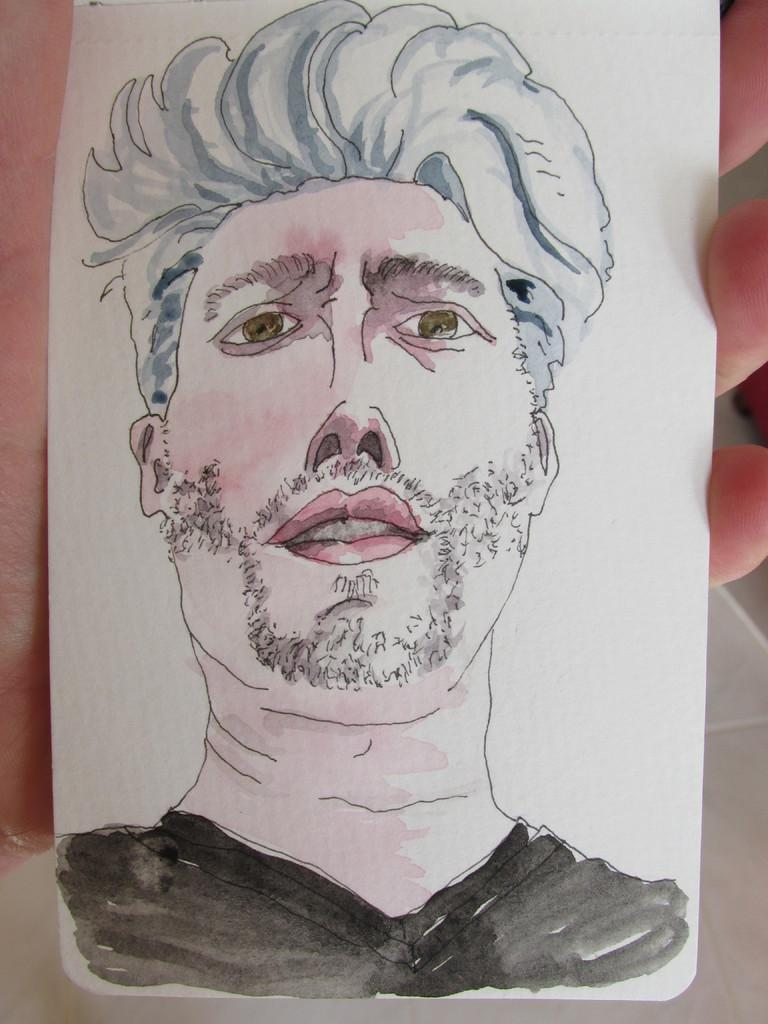What is the main subject of the image? There is a sketch in the image. What language is the crook speaking in the image? There is no crook or language spoken in the image, as it only contains a sketch. 